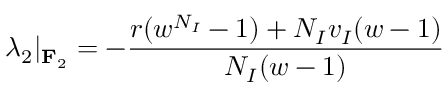Convert formula to latex. <formula><loc_0><loc_0><loc_500><loc_500>\lambda _ { 2 } | _ { F _ { 2 } } = - \frac { r ( w ^ { N _ { I } } - 1 ) + N _ { I } v _ { I } ( w - 1 ) } { N _ { I } ( w - 1 ) }</formula> 